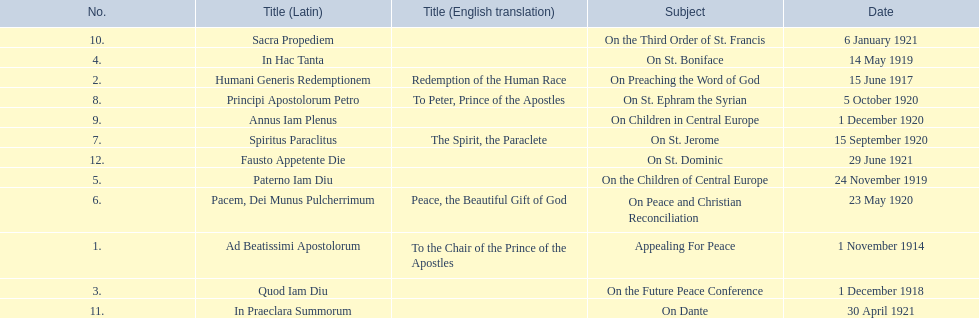What is the dates of the list of encyclicals of pope benedict xv? 1 November 1914, 15 June 1917, 1 December 1918, 14 May 1919, 24 November 1919, 23 May 1920, 15 September 1920, 5 October 1920, 1 December 1920, 6 January 1921, 30 April 1921, 29 June 1921. Of these dates, which subject was on 23 may 1920? On Peace and Christian Reconciliation. 